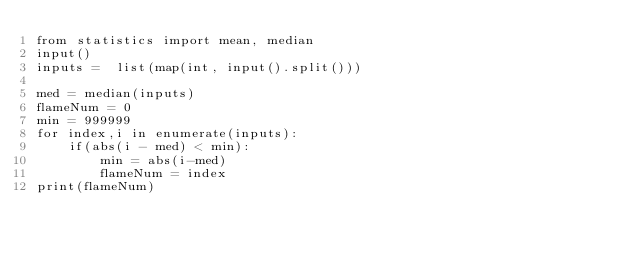Convert code to text. <code><loc_0><loc_0><loc_500><loc_500><_Python_>from statistics import mean, median
input()
inputs =  list(map(int, input().split()))

med = median(inputs)
flameNum = 0
min = 999999
for index,i in enumerate(inputs):
    if(abs(i - med) < min):
        min = abs(i-med)
        flameNum = index
print(flameNum)</code> 